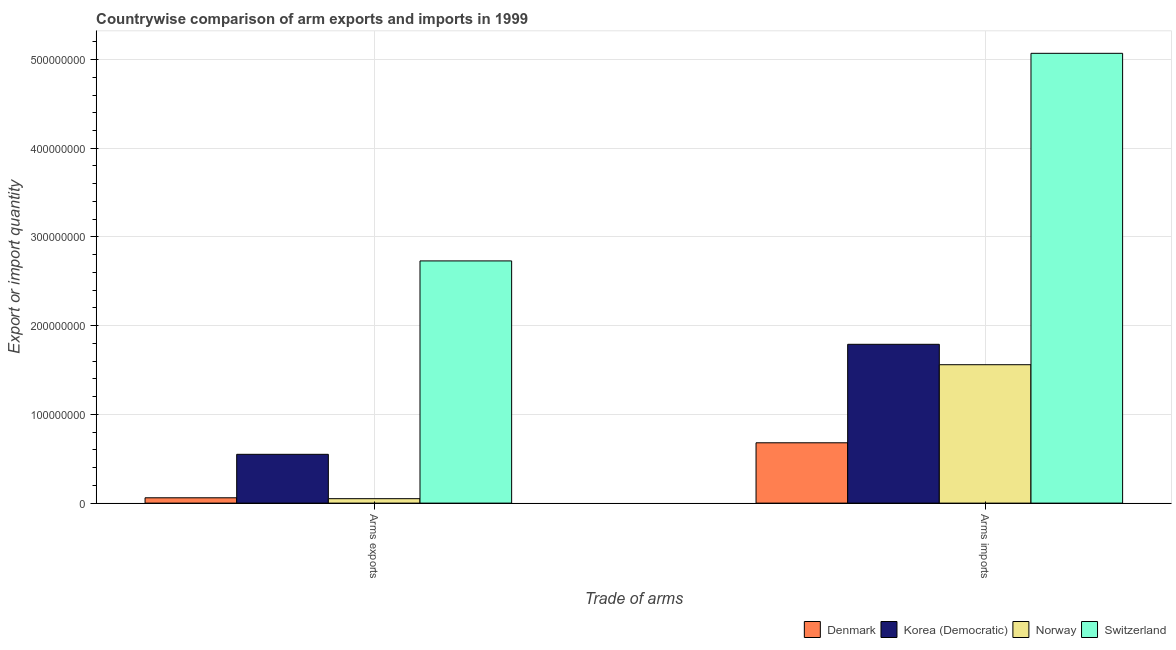Are the number of bars per tick equal to the number of legend labels?
Your answer should be compact. Yes. Are the number of bars on each tick of the X-axis equal?
Make the answer very short. Yes. How many bars are there on the 2nd tick from the left?
Keep it short and to the point. 4. How many bars are there on the 2nd tick from the right?
Keep it short and to the point. 4. What is the label of the 1st group of bars from the left?
Ensure brevity in your answer.  Arms exports. What is the arms imports in Denmark?
Your answer should be compact. 6.80e+07. Across all countries, what is the maximum arms imports?
Your answer should be very brief. 5.07e+08. Across all countries, what is the minimum arms imports?
Provide a succinct answer. 6.80e+07. In which country was the arms imports maximum?
Your answer should be compact. Switzerland. What is the total arms imports in the graph?
Your answer should be compact. 9.10e+08. What is the difference between the arms imports in Denmark and that in Switzerland?
Your response must be concise. -4.39e+08. What is the difference between the arms imports in Korea (Democratic) and the arms exports in Denmark?
Make the answer very short. 1.73e+08. What is the average arms exports per country?
Your answer should be compact. 8.48e+07. What is the difference between the arms imports and arms exports in Denmark?
Ensure brevity in your answer.  6.20e+07. What is the ratio of the arms imports in Korea (Democratic) to that in Denmark?
Offer a very short reply. 2.63. Is the arms imports in Norway less than that in Switzerland?
Provide a short and direct response. Yes. What does the 3rd bar from the left in Arms exports represents?
Give a very brief answer. Norway. How many bars are there?
Offer a terse response. 8. Are all the bars in the graph horizontal?
Ensure brevity in your answer.  No. What is the difference between two consecutive major ticks on the Y-axis?
Give a very brief answer. 1.00e+08. Where does the legend appear in the graph?
Your answer should be very brief. Bottom right. What is the title of the graph?
Ensure brevity in your answer.  Countrywise comparison of arm exports and imports in 1999. Does "Italy" appear as one of the legend labels in the graph?
Make the answer very short. No. What is the label or title of the X-axis?
Ensure brevity in your answer.  Trade of arms. What is the label or title of the Y-axis?
Give a very brief answer. Export or import quantity. What is the Export or import quantity in Denmark in Arms exports?
Ensure brevity in your answer.  6.00e+06. What is the Export or import quantity in Korea (Democratic) in Arms exports?
Your answer should be very brief. 5.50e+07. What is the Export or import quantity of Switzerland in Arms exports?
Offer a very short reply. 2.73e+08. What is the Export or import quantity of Denmark in Arms imports?
Your response must be concise. 6.80e+07. What is the Export or import quantity of Korea (Democratic) in Arms imports?
Keep it short and to the point. 1.79e+08. What is the Export or import quantity of Norway in Arms imports?
Give a very brief answer. 1.56e+08. What is the Export or import quantity in Switzerland in Arms imports?
Give a very brief answer. 5.07e+08. Across all Trade of arms, what is the maximum Export or import quantity of Denmark?
Offer a very short reply. 6.80e+07. Across all Trade of arms, what is the maximum Export or import quantity in Korea (Democratic)?
Your answer should be compact. 1.79e+08. Across all Trade of arms, what is the maximum Export or import quantity of Norway?
Your answer should be compact. 1.56e+08. Across all Trade of arms, what is the maximum Export or import quantity in Switzerland?
Provide a succinct answer. 5.07e+08. Across all Trade of arms, what is the minimum Export or import quantity in Korea (Democratic)?
Your response must be concise. 5.50e+07. Across all Trade of arms, what is the minimum Export or import quantity of Norway?
Your answer should be compact. 5.00e+06. Across all Trade of arms, what is the minimum Export or import quantity of Switzerland?
Provide a succinct answer. 2.73e+08. What is the total Export or import quantity in Denmark in the graph?
Ensure brevity in your answer.  7.40e+07. What is the total Export or import quantity of Korea (Democratic) in the graph?
Give a very brief answer. 2.34e+08. What is the total Export or import quantity of Norway in the graph?
Give a very brief answer. 1.61e+08. What is the total Export or import quantity of Switzerland in the graph?
Provide a short and direct response. 7.80e+08. What is the difference between the Export or import quantity in Denmark in Arms exports and that in Arms imports?
Provide a succinct answer. -6.20e+07. What is the difference between the Export or import quantity in Korea (Democratic) in Arms exports and that in Arms imports?
Offer a very short reply. -1.24e+08. What is the difference between the Export or import quantity of Norway in Arms exports and that in Arms imports?
Provide a short and direct response. -1.51e+08. What is the difference between the Export or import quantity in Switzerland in Arms exports and that in Arms imports?
Your response must be concise. -2.34e+08. What is the difference between the Export or import quantity of Denmark in Arms exports and the Export or import quantity of Korea (Democratic) in Arms imports?
Make the answer very short. -1.73e+08. What is the difference between the Export or import quantity in Denmark in Arms exports and the Export or import quantity in Norway in Arms imports?
Provide a succinct answer. -1.50e+08. What is the difference between the Export or import quantity in Denmark in Arms exports and the Export or import quantity in Switzerland in Arms imports?
Offer a very short reply. -5.01e+08. What is the difference between the Export or import quantity in Korea (Democratic) in Arms exports and the Export or import quantity in Norway in Arms imports?
Provide a short and direct response. -1.01e+08. What is the difference between the Export or import quantity in Korea (Democratic) in Arms exports and the Export or import quantity in Switzerland in Arms imports?
Make the answer very short. -4.52e+08. What is the difference between the Export or import quantity of Norway in Arms exports and the Export or import quantity of Switzerland in Arms imports?
Provide a short and direct response. -5.02e+08. What is the average Export or import quantity of Denmark per Trade of arms?
Your answer should be compact. 3.70e+07. What is the average Export or import quantity in Korea (Democratic) per Trade of arms?
Offer a terse response. 1.17e+08. What is the average Export or import quantity of Norway per Trade of arms?
Your answer should be compact. 8.05e+07. What is the average Export or import quantity of Switzerland per Trade of arms?
Your answer should be compact. 3.90e+08. What is the difference between the Export or import quantity in Denmark and Export or import quantity in Korea (Democratic) in Arms exports?
Provide a short and direct response. -4.90e+07. What is the difference between the Export or import quantity of Denmark and Export or import quantity of Switzerland in Arms exports?
Your response must be concise. -2.67e+08. What is the difference between the Export or import quantity of Korea (Democratic) and Export or import quantity of Norway in Arms exports?
Offer a terse response. 5.00e+07. What is the difference between the Export or import quantity of Korea (Democratic) and Export or import quantity of Switzerland in Arms exports?
Offer a very short reply. -2.18e+08. What is the difference between the Export or import quantity of Norway and Export or import quantity of Switzerland in Arms exports?
Your answer should be very brief. -2.68e+08. What is the difference between the Export or import quantity of Denmark and Export or import quantity of Korea (Democratic) in Arms imports?
Offer a terse response. -1.11e+08. What is the difference between the Export or import quantity of Denmark and Export or import quantity of Norway in Arms imports?
Provide a short and direct response. -8.80e+07. What is the difference between the Export or import quantity in Denmark and Export or import quantity in Switzerland in Arms imports?
Provide a succinct answer. -4.39e+08. What is the difference between the Export or import quantity of Korea (Democratic) and Export or import quantity of Norway in Arms imports?
Your answer should be compact. 2.30e+07. What is the difference between the Export or import quantity of Korea (Democratic) and Export or import quantity of Switzerland in Arms imports?
Make the answer very short. -3.28e+08. What is the difference between the Export or import quantity of Norway and Export or import quantity of Switzerland in Arms imports?
Provide a succinct answer. -3.51e+08. What is the ratio of the Export or import quantity in Denmark in Arms exports to that in Arms imports?
Provide a succinct answer. 0.09. What is the ratio of the Export or import quantity of Korea (Democratic) in Arms exports to that in Arms imports?
Your answer should be compact. 0.31. What is the ratio of the Export or import quantity of Norway in Arms exports to that in Arms imports?
Provide a succinct answer. 0.03. What is the ratio of the Export or import quantity of Switzerland in Arms exports to that in Arms imports?
Offer a very short reply. 0.54. What is the difference between the highest and the second highest Export or import quantity in Denmark?
Keep it short and to the point. 6.20e+07. What is the difference between the highest and the second highest Export or import quantity in Korea (Democratic)?
Your answer should be compact. 1.24e+08. What is the difference between the highest and the second highest Export or import quantity of Norway?
Your response must be concise. 1.51e+08. What is the difference between the highest and the second highest Export or import quantity of Switzerland?
Provide a succinct answer. 2.34e+08. What is the difference between the highest and the lowest Export or import quantity in Denmark?
Your answer should be very brief. 6.20e+07. What is the difference between the highest and the lowest Export or import quantity in Korea (Democratic)?
Offer a terse response. 1.24e+08. What is the difference between the highest and the lowest Export or import quantity in Norway?
Your answer should be compact. 1.51e+08. What is the difference between the highest and the lowest Export or import quantity in Switzerland?
Your response must be concise. 2.34e+08. 